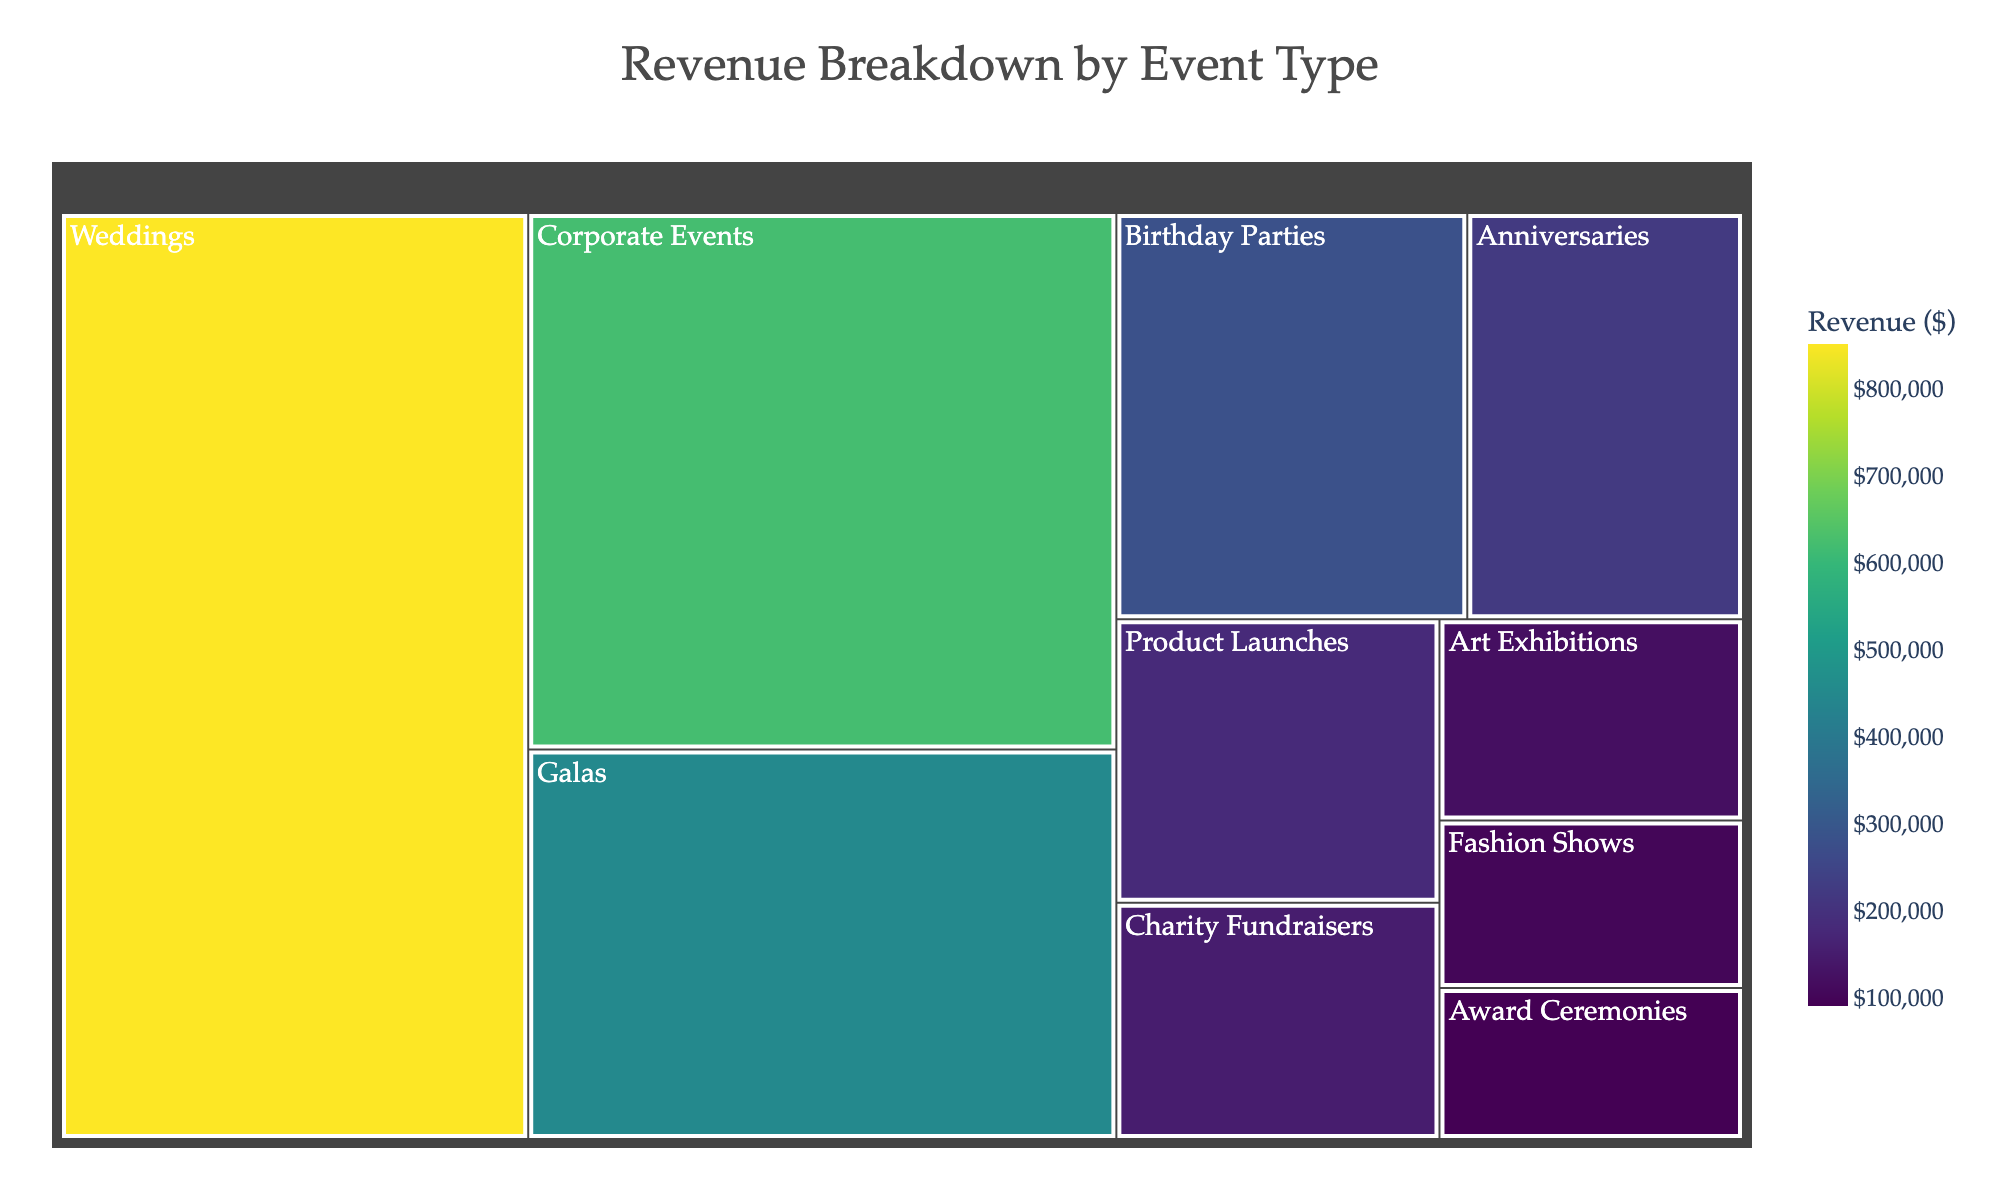What is the title of the treemap? The title is prominently displayed at the top center of the treemap.
Answer: Revenue Breakdown by Event Type Which event type generated the highest revenue? The largest portion of the treemap, indicated by the largest colored block, represents the event type with the highest revenue.
Answer: Weddings How many event types are displayed in the treemap? Count the number of distinct blocks, each representing an event type.
Answer: 10 What is the color scheme used in the treemap? The color scheme is used to represent different levels of revenue, typical for treemaps.
Answer: Viridis What is the revenue of Birthday Parties? Hovering over the relevant block in the treemap will reveal the exact revenue value.
Answer: $280,000 How much more revenue do Corporate Events generate compared to Galas? Subtract the revenue of Galas from the revenue of Corporate Events: $620,000 - $450,000 = $170,000.
Answer: $170,000 Which event type generates the least revenue? The smallest block in the treemap represents the event type with the least revenue.
Answer: Award Ceremonies What is the combined revenue of Product Launches, Charity Fundraisers, and Art Exhibitions? Sum the revenues of the three event types: $180,000 + $150,000 + $120,000 = $450,000.
Answer: $450,000 How do the revenues from Weddings and Corporate Events together compare to the total revenue of all events combined? Add the revenues of Weddings and Corporate Events, then compare the sum to the total revenue: $850,000 + $620,000 = $1,470,000. The total revenue is the sum of all event types’ revenues, which is greater but the former two dominate a significant portion.
Answer: $1,470,000 What is the smallest unit of measurement shown on the color bar for revenue? The color bar displays tick marks which indicate the smallest units, typical of treemaps with financial data.
Answer: $100,000 